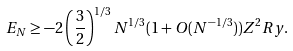Convert formula to latex. <formula><loc_0><loc_0><loc_500><loc_500>E _ { N } \geq - 2 \left ( \frac { 3 } { 2 } \right ) ^ { 1 / 3 } N ^ { 1 / 3 } ( 1 + O ( N ^ { - 1 / 3 } ) ) Z ^ { 2 } R y .</formula> 